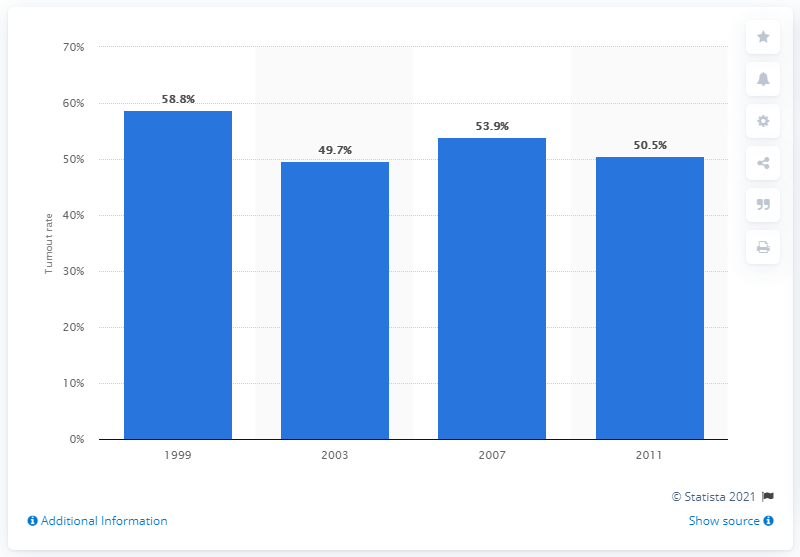Specify some key components in this picture. The lowest turnout rate of the last four elections occurred in 2003. 